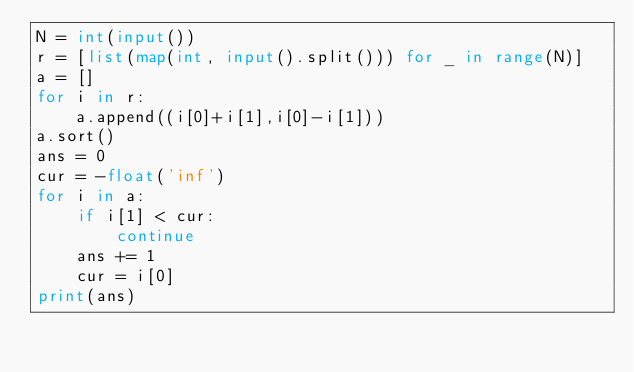<code> <loc_0><loc_0><loc_500><loc_500><_Python_>N = int(input())
r = [list(map(int, input().split())) for _ in range(N)]
a = []
for i in r:
    a.append((i[0]+i[1],i[0]-i[1]))
a.sort()
ans = 0
cur = -float('inf')
for i in a:
    if i[1] < cur:
        continue
    ans += 1
    cur = i[0]
print(ans)</code> 